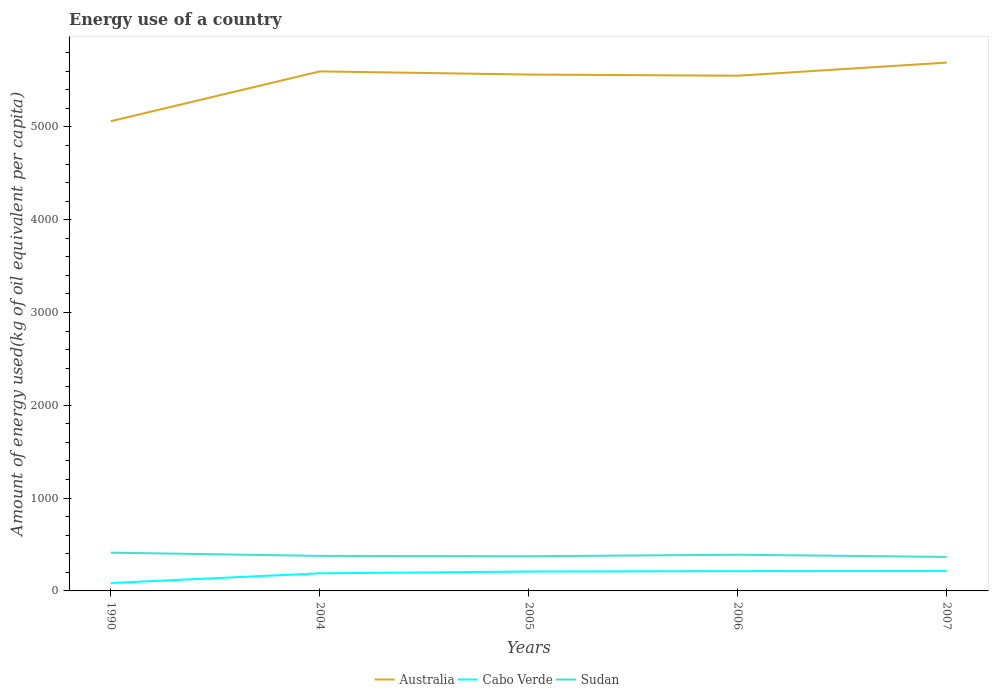Does the line corresponding to Cabo Verde intersect with the line corresponding to Australia?
Keep it short and to the point. No. Across all years, what is the maximum amount of energy used in in Sudan?
Offer a very short reply. 366.5. What is the total amount of energy used in in Cabo Verde in the graph?
Ensure brevity in your answer.  -24.24. What is the difference between the highest and the second highest amount of energy used in in Cabo Verde?
Make the answer very short. 128.9. Are the values on the major ticks of Y-axis written in scientific E-notation?
Your answer should be compact. No. Does the graph contain grids?
Make the answer very short. No. Where does the legend appear in the graph?
Offer a very short reply. Bottom center. What is the title of the graph?
Your answer should be compact. Energy use of a country. Does "Sub-Saharan Africa (developing only)" appear as one of the legend labels in the graph?
Give a very brief answer. No. What is the label or title of the Y-axis?
Provide a short and direct response. Amount of energy used(kg of oil equivalent per capita). What is the Amount of energy used(kg of oil equivalent per capita) in Australia in 1990?
Provide a short and direct response. 5061.51. What is the Amount of energy used(kg of oil equivalent per capita) in Cabo Verde in 1990?
Provide a succinct answer. 85.12. What is the Amount of energy used(kg of oil equivalent per capita) in Sudan in 1990?
Keep it short and to the point. 412.46. What is the Amount of energy used(kg of oil equivalent per capita) in Australia in 2004?
Ensure brevity in your answer.  5598.09. What is the Amount of energy used(kg of oil equivalent per capita) of Cabo Verde in 2004?
Ensure brevity in your answer.  189.77. What is the Amount of energy used(kg of oil equivalent per capita) of Sudan in 2004?
Your response must be concise. 377.4. What is the Amount of energy used(kg of oil equivalent per capita) of Australia in 2005?
Your answer should be compact. 5564.09. What is the Amount of energy used(kg of oil equivalent per capita) in Cabo Verde in 2005?
Offer a very short reply. 208.76. What is the Amount of energy used(kg of oil equivalent per capita) in Sudan in 2005?
Give a very brief answer. 373.63. What is the Amount of energy used(kg of oil equivalent per capita) of Australia in 2006?
Your answer should be very brief. 5551.5. What is the Amount of energy used(kg of oil equivalent per capita) in Cabo Verde in 2006?
Keep it short and to the point. 213.27. What is the Amount of energy used(kg of oil equivalent per capita) in Sudan in 2006?
Your answer should be very brief. 390. What is the Amount of energy used(kg of oil equivalent per capita) of Australia in 2007?
Offer a very short reply. 5692.93. What is the Amount of energy used(kg of oil equivalent per capita) in Cabo Verde in 2007?
Make the answer very short. 214.01. What is the Amount of energy used(kg of oil equivalent per capita) of Sudan in 2007?
Your answer should be compact. 366.5. Across all years, what is the maximum Amount of energy used(kg of oil equivalent per capita) in Australia?
Keep it short and to the point. 5692.93. Across all years, what is the maximum Amount of energy used(kg of oil equivalent per capita) in Cabo Verde?
Ensure brevity in your answer.  214.01. Across all years, what is the maximum Amount of energy used(kg of oil equivalent per capita) of Sudan?
Keep it short and to the point. 412.46. Across all years, what is the minimum Amount of energy used(kg of oil equivalent per capita) in Australia?
Give a very brief answer. 5061.51. Across all years, what is the minimum Amount of energy used(kg of oil equivalent per capita) of Cabo Verde?
Keep it short and to the point. 85.12. Across all years, what is the minimum Amount of energy used(kg of oil equivalent per capita) of Sudan?
Your response must be concise. 366.5. What is the total Amount of energy used(kg of oil equivalent per capita) in Australia in the graph?
Give a very brief answer. 2.75e+04. What is the total Amount of energy used(kg of oil equivalent per capita) of Cabo Verde in the graph?
Your response must be concise. 910.93. What is the total Amount of energy used(kg of oil equivalent per capita) of Sudan in the graph?
Offer a very short reply. 1919.98. What is the difference between the Amount of energy used(kg of oil equivalent per capita) in Australia in 1990 and that in 2004?
Give a very brief answer. -536.58. What is the difference between the Amount of energy used(kg of oil equivalent per capita) of Cabo Verde in 1990 and that in 2004?
Provide a short and direct response. -104.66. What is the difference between the Amount of energy used(kg of oil equivalent per capita) in Sudan in 1990 and that in 2004?
Keep it short and to the point. 35.06. What is the difference between the Amount of energy used(kg of oil equivalent per capita) of Australia in 1990 and that in 2005?
Provide a succinct answer. -502.58. What is the difference between the Amount of energy used(kg of oil equivalent per capita) of Cabo Verde in 1990 and that in 2005?
Keep it short and to the point. -123.65. What is the difference between the Amount of energy used(kg of oil equivalent per capita) in Sudan in 1990 and that in 2005?
Ensure brevity in your answer.  38.83. What is the difference between the Amount of energy used(kg of oil equivalent per capita) in Australia in 1990 and that in 2006?
Keep it short and to the point. -490. What is the difference between the Amount of energy used(kg of oil equivalent per capita) in Cabo Verde in 1990 and that in 2006?
Provide a succinct answer. -128.16. What is the difference between the Amount of energy used(kg of oil equivalent per capita) in Sudan in 1990 and that in 2006?
Your answer should be very brief. 22.46. What is the difference between the Amount of energy used(kg of oil equivalent per capita) in Australia in 1990 and that in 2007?
Offer a terse response. -631.42. What is the difference between the Amount of energy used(kg of oil equivalent per capita) of Cabo Verde in 1990 and that in 2007?
Provide a short and direct response. -128.9. What is the difference between the Amount of energy used(kg of oil equivalent per capita) of Sudan in 1990 and that in 2007?
Offer a terse response. 45.96. What is the difference between the Amount of energy used(kg of oil equivalent per capita) of Australia in 2004 and that in 2005?
Offer a very short reply. 34. What is the difference between the Amount of energy used(kg of oil equivalent per capita) in Cabo Verde in 2004 and that in 2005?
Your response must be concise. -18.99. What is the difference between the Amount of energy used(kg of oil equivalent per capita) of Sudan in 2004 and that in 2005?
Provide a succinct answer. 3.77. What is the difference between the Amount of energy used(kg of oil equivalent per capita) in Australia in 2004 and that in 2006?
Your answer should be very brief. 46.58. What is the difference between the Amount of energy used(kg of oil equivalent per capita) in Cabo Verde in 2004 and that in 2006?
Offer a terse response. -23.5. What is the difference between the Amount of energy used(kg of oil equivalent per capita) in Sudan in 2004 and that in 2006?
Make the answer very short. -12.6. What is the difference between the Amount of energy used(kg of oil equivalent per capita) in Australia in 2004 and that in 2007?
Make the answer very short. -94.84. What is the difference between the Amount of energy used(kg of oil equivalent per capita) of Cabo Verde in 2004 and that in 2007?
Your response must be concise. -24.24. What is the difference between the Amount of energy used(kg of oil equivalent per capita) in Sudan in 2004 and that in 2007?
Provide a succinct answer. 10.9. What is the difference between the Amount of energy used(kg of oil equivalent per capita) in Australia in 2005 and that in 2006?
Offer a very short reply. 12.58. What is the difference between the Amount of energy used(kg of oil equivalent per capita) in Cabo Verde in 2005 and that in 2006?
Provide a short and direct response. -4.51. What is the difference between the Amount of energy used(kg of oil equivalent per capita) of Sudan in 2005 and that in 2006?
Your response must be concise. -16.37. What is the difference between the Amount of energy used(kg of oil equivalent per capita) in Australia in 2005 and that in 2007?
Provide a short and direct response. -128.84. What is the difference between the Amount of energy used(kg of oil equivalent per capita) of Cabo Verde in 2005 and that in 2007?
Offer a very short reply. -5.25. What is the difference between the Amount of energy used(kg of oil equivalent per capita) in Sudan in 2005 and that in 2007?
Your answer should be very brief. 7.13. What is the difference between the Amount of energy used(kg of oil equivalent per capita) in Australia in 2006 and that in 2007?
Your answer should be very brief. -141.42. What is the difference between the Amount of energy used(kg of oil equivalent per capita) in Cabo Verde in 2006 and that in 2007?
Your answer should be very brief. -0.74. What is the difference between the Amount of energy used(kg of oil equivalent per capita) of Sudan in 2006 and that in 2007?
Your answer should be compact. 23.5. What is the difference between the Amount of energy used(kg of oil equivalent per capita) of Australia in 1990 and the Amount of energy used(kg of oil equivalent per capita) of Cabo Verde in 2004?
Give a very brief answer. 4871.74. What is the difference between the Amount of energy used(kg of oil equivalent per capita) of Australia in 1990 and the Amount of energy used(kg of oil equivalent per capita) of Sudan in 2004?
Your response must be concise. 4684.11. What is the difference between the Amount of energy used(kg of oil equivalent per capita) in Cabo Verde in 1990 and the Amount of energy used(kg of oil equivalent per capita) in Sudan in 2004?
Your response must be concise. -292.28. What is the difference between the Amount of energy used(kg of oil equivalent per capita) of Australia in 1990 and the Amount of energy used(kg of oil equivalent per capita) of Cabo Verde in 2005?
Provide a short and direct response. 4852.75. What is the difference between the Amount of energy used(kg of oil equivalent per capita) of Australia in 1990 and the Amount of energy used(kg of oil equivalent per capita) of Sudan in 2005?
Your answer should be very brief. 4687.88. What is the difference between the Amount of energy used(kg of oil equivalent per capita) in Cabo Verde in 1990 and the Amount of energy used(kg of oil equivalent per capita) in Sudan in 2005?
Your response must be concise. -288.51. What is the difference between the Amount of energy used(kg of oil equivalent per capita) in Australia in 1990 and the Amount of energy used(kg of oil equivalent per capita) in Cabo Verde in 2006?
Make the answer very short. 4848.24. What is the difference between the Amount of energy used(kg of oil equivalent per capita) of Australia in 1990 and the Amount of energy used(kg of oil equivalent per capita) of Sudan in 2006?
Make the answer very short. 4671.51. What is the difference between the Amount of energy used(kg of oil equivalent per capita) of Cabo Verde in 1990 and the Amount of energy used(kg of oil equivalent per capita) of Sudan in 2006?
Provide a succinct answer. -304.88. What is the difference between the Amount of energy used(kg of oil equivalent per capita) in Australia in 1990 and the Amount of energy used(kg of oil equivalent per capita) in Cabo Verde in 2007?
Your answer should be very brief. 4847.49. What is the difference between the Amount of energy used(kg of oil equivalent per capita) in Australia in 1990 and the Amount of energy used(kg of oil equivalent per capita) in Sudan in 2007?
Give a very brief answer. 4695.01. What is the difference between the Amount of energy used(kg of oil equivalent per capita) in Cabo Verde in 1990 and the Amount of energy used(kg of oil equivalent per capita) in Sudan in 2007?
Provide a succinct answer. -281.38. What is the difference between the Amount of energy used(kg of oil equivalent per capita) in Australia in 2004 and the Amount of energy used(kg of oil equivalent per capita) in Cabo Verde in 2005?
Ensure brevity in your answer.  5389.33. What is the difference between the Amount of energy used(kg of oil equivalent per capita) in Australia in 2004 and the Amount of energy used(kg of oil equivalent per capita) in Sudan in 2005?
Provide a short and direct response. 5224.46. What is the difference between the Amount of energy used(kg of oil equivalent per capita) in Cabo Verde in 2004 and the Amount of energy used(kg of oil equivalent per capita) in Sudan in 2005?
Your answer should be very brief. -183.86. What is the difference between the Amount of energy used(kg of oil equivalent per capita) in Australia in 2004 and the Amount of energy used(kg of oil equivalent per capita) in Cabo Verde in 2006?
Give a very brief answer. 5384.82. What is the difference between the Amount of energy used(kg of oil equivalent per capita) of Australia in 2004 and the Amount of energy used(kg of oil equivalent per capita) of Sudan in 2006?
Keep it short and to the point. 5208.09. What is the difference between the Amount of energy used(kg of oil equivalent per capita) of Cabo Verde in 2004 and the Amount of energy used(kg of oil equivalent per capita) of Sudan in 2006?
Keep it short and to the point. -200.23. What is the difference between the Amount of energy used(kg of oil equivalent per capita) of Australia in 2004 and the Amount of energy used(kg of oil equivalent per capita) of Cabo Verde in 2007?
Your response must be concise. 5384.07. What is the difference between the Amount of energy used(kg of oil equivalent per capita) of Australia in 2004 and the Amount of energy used(kg of oil equivalent per capita) of Sudan in 2007?
Your answer should be compact. 5231.59. What is the difference between the Amount of energy used(kg of oil equivalent per capita) in Cabo Verde in 2004 and the Amount of energy used(kg of oil equivalent per capita) in Sudan in 2007?
Offer a very short reply. -176.72. What is the difference between the Amount of energy used(kg of oil equivalent per capita) in Australia in 2005 and the Amount of energy used(kg of oil equivalent per capita) in Cabo Verde in 2006?
Offer a terse response. 5350.82. What is the difference between the Amount of energy used(kg of oil equivalent per capita) in Australia in 2005 and the Amount of energy used(kg of oil equivalent per capita) in Sudan in 2006?
Provide a succinct answer. 5174.09. What is the difference between the Amount of energy used(kg of oil equivalent per capita) in Cabo Verde in 2005 and the Amount of energy used(kg of oil equivalent per capita) in Sudan in 2006?
Provide a succinct answer. -181.23. What is the difference between the Amount of energy used(kg of oil equivalent per capita) of Australia in 2005 and the Amount of energy used(kg of oil equivalent per capita) of Cabo Verde in 2007?
Make the answer very short. 5350.07. What is the difference between the Amount of energy used(kg of oil equivalent per capita) in Australia in 2005 and the Amount of energy used(kg of oil equivalent per capita) in Sudan in 2007?
Your answer should be very brief. 5197.59. What is the difference between the Amount of energy used(kg of oil equivalent per capita) of Cabo Verde in 2005 and the Amount of energy used(kg of oil equivalent per capita) of Sudan in 2007?
Keep it short and to the point. -157.73. What is the difference between the Amount of energy used(kg of oil equivalent per capita) in Australia in 2006 and the Amount of energy used(kg of oil equivalent per capita) in Cabo Verde in 2007?
Give a very brief answer. 5337.49. What is the difference between the Amount of energy used(kg of oil equivalent per capita) in Australia in 2006 and the Amount of energy used(kg of oil equivalent per capita) in Sudan in 2007?
Your response must be concise. 5185.01. What is the difference between the Amount of energy used(kg of oil equivalent per capita) of Cabo Verde in 2006 and the Amount of energy used(kg of oil equivalent per capita) of Sudan in 2007?
Your response must be concise. -153.22. What is the average Amount of energy used(kg of oil equivalent per capita) of Australia per year?
Your answer should be very brief. 5493.62. What is the average Amount of energy used(kg of oil equivalent per capita) of Cabo Verde per year?
Your answer should be compact. 182.19. What is the average Amount of energy used(kg of oil equivalent per capita) of Sudan per year?
Ensure brevity in your answer.  384. In the year 1990, what is the difference between the Amount of energy used(kg of oil equivalent per capita) in Australia and Amount of energy used(kg of oil equivalent per capita) in Cabo Verde?
Provide a short and direct response. 4976.39. In the year 1990, what is the difference between the Amount of energy used(kg of oil equivalent per capita) of Australia and Amount of energy used(kg of oil equivalent per capita) of Sudan?
Provide a short and direct response. 4649.05. In the year 1990, what is the difference between the Amount of energy used(kg of oil equivalent per capita) in Cabo Verde and Amount of energy used(kg of oil equivalent per capita) in Sudan?
Provide a short and direct response. -327.34. In the year 2004, what is the difference between the Amount of energy used(kg of oil equivalent per capita) in Australia and Amount of energy used(kg of oil equivalent per capita) in Cabo Verde?
Provide a short and direct response. 5408.32. In the year 2004, what is the difference between the Amount of energy used(kg of oil equivalent per capita) of Australia and Amount of energy used(kg of oil equivalent per capita) of Sudan?
Keep it short and to the point. 5220.69. In the year 2004, what is the difference between the Amount of energy used(kg of oil equivalent per capita) of Cabo Verde and Amount of energy used(kg of oil equivalent per capita) of Sudan?
Keep it short and to the point. -187.63. In the year 2005, what is the difference between the Amount of energy used(kg of oil equivalent per capita) of Australia and Amount of energy used(kg of oil equivalent per capita) of Cabo Verde?
Your response must be concise. 5355.33. In the year 2005, what is the difference between the Amount of energy used(kg of oil equivalent per capita) in Australia and Amount of energy used(kg of oil equivalent per capita) in Sudan?
Offer a very short reply. 5190.46. In the year 2005, what is the difference between the Amount of energy used(kg of oil equivalent per capita) in Cabo Verde and Amount of energy used(kg of oil equivalent per capita) in Sudan?
Ensure brevity in your answer.  -164.87. In the year 2006, what is the difference between the Amount of energy used(kg of oil equivalent per capita) in Australia and Amount of energy used(kg of oil equivalent per capita) in Cabo Verde?
Make the answer very short. 5338.23. In the year 2006, what is the difference between the Amount of energy used(kg of oil equivalent per capita) of Australia and Amount of energy used(kg of oil equivalent per capita) of Sudan?
Provide a succinct answer. 5161.51. In the year 2006, what is the difference between the Amount of energy used(kg of oil equivalent per capita) of Cabo Verde and Amount of energy used(kg of oil equivalent per capita) of Sudan?
Provide a succinct answer. -176.73. In the year 2007, what is the difference between the Amount of energy used(kg of oil equivalent per capita) in Australia and Amount of energy used(kg of oil equivalent per capita) in Cabo Verde?
Offer a very short reply. 5478.91. In the year 2007, what is the difference between the Amount of energy used(kg of oil equivalent per capita) in Australia and Amount of energy used(kg of oil equivalent per capita) in Sudan?
Your answer should be compact. 5326.43. In the year 2007, what is the difference between the Amount of energy used(kg of oil equivalent per capita) of Cabo Verde and Amount of energy used(kg of oil equivalent per capita) of Sudan?
Offer a very short reply. -152.48. What is the ratio of the Amount of energy used(kg of oil equivalent per capita) of Australia in 1990 to that in 2004?
Your answer should be compact. 0.9. What is the ratio of the Amount of energy used(kg of oil equivalent per capita) of Cabo Verde in 1990 to that in 2004?
Offer a very short reply. 0.45. What is the ratio of the Amount of energy used(kg of oil equivalent per capita) in Sudan in 1990 to that in 2004?
Ensure brevity in your answer.  1.09. What is the ratio of the Amount of energy used(kg of oil equivalent per capita) of Australia in 1990 to that in 2005?
Ensure brevity in your answer.  0.91. What is the ratio of the Amount of energy used(kg of oil equivalent per capita) of Cabo Verde in 1990 to that in 2005?
Your answer should be compact. 0.41. What is the ratio of the Amount of energy used(kg of oil equivalent per capita) in Sudan in 1990 to that in 2005?
Ensure brevity in your answer.  1.1. What is the ratio of the Amount of energy used(kg of oil equivalent per capita) in Australia in 1990 to that in 2006?
Your response must be concise. 0.91. What is the ratio of the Amount of energy used(kg of oil equivalent per capita) in Cabo Verde in 1990 to that in 2006?
Your answer should be very brief. 0.4. What is the ratio of the Amount of energy used(kg of oil equivalent per capita) of Sudan in 1990 to that in 2006?
Your answer should be very brief. 1.06. What is the ratio of the Amount of energy used(kg of oil equivalent per capita) of Australia in 1990 to that in 2007?
Your response must be concise. 0.89. What is the ratio of the Amount of energy used(kg of oil equivalent per capita) of Cabo Verde in 1990 to that in 2007?
Offer a terse response. 0.4. What is the ratio of the Amount of energy used(kg of oil equivalent per capita) in Sudan in 1990 to that in 2007?
Your answer should be compact. 1.13. What is the ratio of the Amount of energy used(kg of oil equivalent per capita) of Australia in 2004 to that in 2005?
Your response must be concise. 1.01. What is the ratio of the Amount of energy used(kg of oil equivalent per capita) in Cabo Verde in 2004 to that in 2005?
Keep it short and to the point. 0.91. What is the ratio of the Amount of energy used(kg of oil equivalent per capita) of Sudan in 2004 to that in 2005?
Give a very brief answer. 1.01. What is the ratio of the Amount of energy used(kg of oil equivalent per capita) of Australia in 2004 to that in 2006?
Your answer should be very brief. 1.01. What is the ratio of the Amount of energy used(kg of oil equivalent per capita) in Cabo Verde in 2004 to that in 2006?
Provide a short and direct response. 0.89. What is the ratio of the Amount of energy used(kg of oil equivalent per capita) in Australia in 2004 to that in 2007?
Your answer should be compact. 0.98. What is the ratio of the Amount of energy used(kg of oil equivalent per capita) of Cabo Verde in 2004 to that in 2007?
Provide a short and direct response. 0.89. What is the ratio of the Amount of energy used(kg of oil equivalent per capita) of Sudan in 2004 to that in 2007?
Offer a terse response. 1.03. What is the ratio of the Amount of energy used(kg of oil equivalent per capita) of Cabo Verde in 2005 to that in 2006?
Give a very brief answer. 0.98. What is the ratio of the Amount of energy used(kg of oil equivalent per capita) of Sudan in 2005 to that in 2006?
Your answer should be compact. 0.96. What is the ratio of the Amount of energy used(kg of oil equivalent per capita) of Australia in 2005 to that in 2007?
Your response must be concise. 0.98. What is the ratio of the Amount of energy used(kg of oil equivalent per capita) in Cabo Verde in 2005 to that in 2007?
Offer a terse response. 0.98. What is the ratio of the Amount of energy used(kg of oil equivalent per capita) in Sudan in 2005 to that in 2007?
Your response must be concise. 1.02. What is the ratio of the Amount of energy used(kg of oil equivalent per capita) in Australia in 2006 to that in 2007?
Offer a very short reply. 0.98. What is the ratio of the Amount of energy used(kg of oil equivalent per capita) of Cabo Verde in 2006 to that in 2007?
Ensure brevity in your answer.  1. What is the ratio of the Amount of energy used(kg of oil equivalent per capita) in Sudan in 2006 to that in 2007?
Offer a terse response. 1.06. What is the difference between the highest and the second highest Amount of energy used(kg of oil equivalent per capita) of Australia?
Offer a terse response. 94.84. What is the difference between the highest and the second highest Amount of energy used(kg of oil equivalent per capita) in Cabo Verde?
Offer a very short reply. 0.74. What is the difference between the highest and the second highest Amount of energy used(kg of oil equivalent per capita) of Sudan?
Keep it short and to the point. 22.46. What is the difference between the highest and the lowest Amount of energy used(kg of oil equivalent per capita) of Australia?
Ensure brevity in your answer.  631.42. What is the difference between the highest and the lowest Amount of energy used(kg of oil equivalent per capita) in Cabo Verde?
Offer a very short reply. 128.9. What is the difference between the highest and the lowest Amount of energy used(kg of oil equivalent per capita) of Sudan?
Make the answer very short. 45.96. 